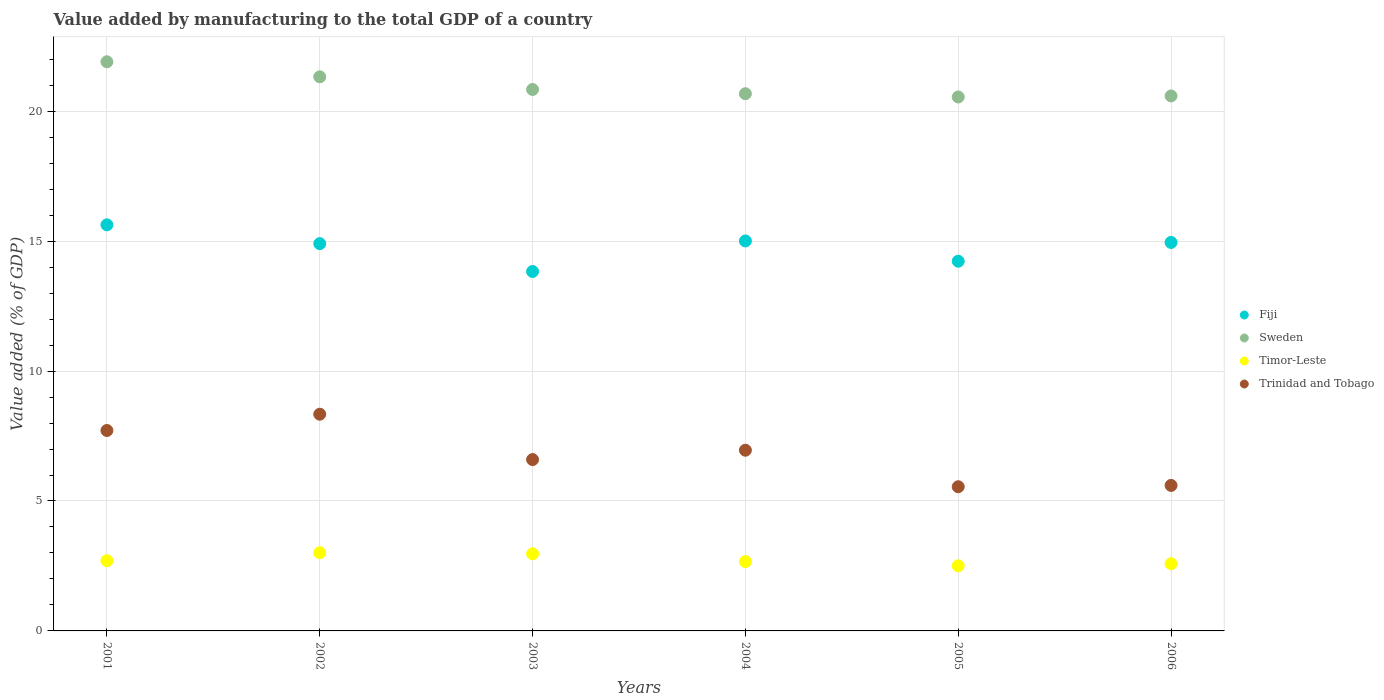How many different coloured dotlines are there?
Ensure brevity in your answer.  4. Is the number of dotlines equal to the number of legend labels?
Make the answer very short. Yes. What is the value added by manufacturing to the total GDP in Sweden in 2006?
Provide a short and direct response. 20.59. Across all years, what is the maximum value added by manufacturing to the total GDP in Fiji?
Keep it short and to the point. 15.63. Across all years, what is the minimum value added by manufacturing to the total GDP in Timor-Leste?
Offer a very short reply. 2.51. What is the total value added by manufacturing to the total GDP in Timor-Leste in the graph?
Offer a very short reply. 16.44. What is the difference between the value added by manufacturing to the total GDP in Trinidad and Tobago in 2002 and that in 2003?
Provide a short and direct response. 1.75. What is the difference between the value added by manufacturing to the total GDP in Timor-Leste in 2004 and the value added by manufacturing to the total GDP in Sweden in 2003?
Your answer should be compact. -18.17. What is the average value added by manufacturing to the total GDP in Sweden per year?
Provide a short and direct response. 20.98. In the year 2004, what is the difference between the value added by manufacturing to the total GDP in Timor-Leste and value added by manufacturing to the total GDP in Trinidad and Tobago?
Your response must be concise. -4.29. What is the ratio of the value added by manufacturing to the total GDP in Trinidad and Tobago in 2004 to that in 2005?
Keep it short and to the point. 1.25. Is the difference between the value added by manufacturing to the total GDP in Timor-Leste in 2002 and 2006 greater than the difference between the value added by manufacturing to the total GDP in Trinidad and Tobago in 2002 and 2006?
Your answer should be compact. No. What is the difference between the highest and the second highest value added by manufacturing to the total GDP in Trinidad and Tobago?
Your response must be concise. 0.63. What is the difference between the highest and the lowest value added by manufacturing to the total GDP in Sweden?
Your response must be concise. 1.35. Is the sum of the value added by manufacturing to the total GDP in Sweden in 2003 and 2005 greater than the maximum value added by manufacturing to the total GDP in Trinidad and Tobago across all years?
Offer a terse response. Yes. Is the value added by manufacturing to the total GDP in Sweden strictly greater than the value added by manufacturing to the total GDP in Timor-Leste over the years?
Ensure brevity in your answer.  Yes. How many dotlines are there?
Provide a short and direct response. 4. How many years are there in the graph?
Make the answer very short. 6. Are the values on the major ticks of Y-axis written in scientific E-notation?
Offer a terse response. No. What is the title of the graph?
Make the answer very short. Value added by manufacturing to the total GDP of a country. Does "Lao PDR" appear as one of the legend labels in the graph?
Ensure brevity in your answer.  No. What is the label or title of the X-axis?
Your response must be concise. Years. What is the label or title of the Y-axis?
Give a very brief answer. Value added (% of GDP). What is the Value added (% of GDP) of Fiji in 2001?
Offer a terse response. 15.63. What is the Value added (% of GDP) in Sweden in 2001?
Your answer should be compact. 21.9. What is the Value added (% of GDP) in Timor-Leste in 2001?
Provide a succinct answer. 2.7. What is the Value added (% of GDP) in Trinidad and Tobago in 2001?
Ensure brevity in your answer.  7.71. What is the Value added (% of GDP) of Fiji in 2002?
Offer a very short reply. 14.9. What is the Value added (% of GDP) of Sweden in 2002?
Provide a short and direct response. 21.32. What is the Value added (% of GDP) in Timor-Leste in 2002?
Ensure brevity in your answer.  3.01. What is the Value added (% of GDP) of Trinidad and Tobago in 2002?
Offer a very short reply. 8.34. What is the Value added (% of GDP) of Fiji in 2003?
Offer a very short reply. 13.83. What is the Value added (% of GDP) of Sweden in 2003?
Provide a short and direct response. 20.84. What is the Value added (% of GDP) in Timor-Leste in 2003?
Ensure brevity in your answer.  2.97. What is the Value added (% of GDP) of Trinidad and Tobago in 2003?
Keep it short and to the point. 6.59. What is the Value added (% of GDP) in Fiji in 2004?
Make the answer very short. 15.01. What is the Value added (% of GDP) in Sweden in 2004?
Give a very brief answer. 20.67. What is the Value added (% of GDP) of Timor-Leste in 2004?
Keep it short and to the point. 2.67. What is the Value added (% of GDP) in Trinidad and Tobago in 2004?
Give a very brief answer. 6.95. What is the Value added (% of GDP) in Fiji in 2005?
Make the answer very short. 14.23. What is the Value added (% of GDP) in Sweden in 2005?
Give a very brief answer. 20.55. What is the Value added (% of GDP) in Timor-Leste in 2005?
Your answer should be compact. 2.51. What is the Value added (% of GDP) of Trinidad and Tobago in 2005?
Ensure brevity in your answer.  5.55. What is the Value added (% of GDP) in Fiji in 2006?
Ensure brevity in your answer.  14.95. What is the Value added (% of GDP) in Sweden in 2006?
Keep it short and to the point. 20.59. What is the Value added (% of GDP) of Timor-Leste in 2006?
Your response must be concise. 2.59. What is the Value added (% of GDP) of Trinidad and Tobago in 2006?
Give a very brief answer. 5.6. Across all years, what is the maximum Value added (% of GDP) of Fiji?
Ensure brevity in your answer.  15.63. Across all years, what is the maximum Value added (% of GDP) in Sweden?
Your response must be concise. 21.9. Across all years, what is the maximum Value added (% of GDP) of Timor-Leste?
Your answer should be compact. 3.01. Across all years, what is the maximum Value added (% of GDP) in Trinidad and Tobago?
Provide a succinct answer. 8.34. Across all years, what is the minimum Value added (% of GDP) in Fiji?
Provide a succinct answer. 13.83. Across all years, what is the minimum Value added (% of GDP) in Sweden?
Provide a short and direct response. 20.55. Across all years, what is the minimum Value added (% of GDP) in Timor-Leste?
Provide a short and direct response. 2.51. Across all years, what is the minimum Value added (% of GDP) of Trinidad and Tobago?
Keep it short and to the point. 5.55. What is the total Value added (% of GDP) of Fiji in the graph?
Keep it short and to the point. 88.54. What is the total Value added (% of GDP) of Sweden in the graph?
Keep it short and to the point. 125.87. What is the total Value added (% of GDP) in Timor-Leste in the graph?
Keep it short and to the point. 16.44. What is the total Value added (% of GDP) in Trinidad and Tobago in the graph?
Your answer should be very brief. 40.75. What is the difference between the Value added (% of GDP) of Fiji in 2001 and that in 2002?
Your response must be concise. 0.72. What is the difference between the Value added (% of GDP) of Sweden in 2001 and that in 2002?
Ensure brevity in your answer.  0.58. What is the difference between the Value added (% of GDP) in Timor-Leste in 2001 and that in 2002?
Give a very brief answer. -0.31. What is the difference between the Value added (% of GDP) in Trinidad and Tobago in 2001 and that in 2002?
Ensure brevity in your answer.  -0.63. What is the difference between the Value added (% of GDP) in Fiji in 2001 and that in 2003?
Your response must be concise. 1.8. What is the difference between the Value added (% of GDP) of Sweden in 2001 and that in 2003?
Your answer should be very brief. 1.07. What is the difference between the Value added (% of GDP) in Timor-Leste in 2001 and that in 2003?
Your answer should be compact. -0.27. What is the difference between the Value added (% of GDP) in Trinidad and Tobago in 2001 and that in 2003?
Give a very brief answer. 1.12. What is the difference between the Value added (% of GDP) in Fiji in 2001 and that in 2004?
Your answer should be very brief. 0.62. What is the difference between the Value added (% of GDP) of Sweden in 2001 and that in 2004?
Your response must be concise. 1.23. What is the difference between the Value added (% of GDP) in Timor-Leste in 2001 and that in 2004?
Your answer should be very brief. 0.04. What is the difference between the Value added (% of GDP) in Trinidad and Tobago in 2001 and that in 2004?
Ensure brevity in your answer.  0.76. What is the difference between the Value added (% of GDP) of Fiji in 2001 and that in 2005?
Offer a very short reply. 1.4. What is the difference between the Value added (% of GDP) of Sweden in 2001 and that in 2005?
Your response must be concise. 1.35. What is the difference between the Value added (% of GDP) in Timor-Leste in 2001 and that in 2005?
Your response must be concise. 0.2. What is the difference between the Value added (% of GDP) in Trinidad and Tobago in 2001 and that in 2005?
Keep it short and to the point. 2.16. What is the difference between the Value added (% of GDP) of Fiji in 2001 and that in 2006?
Offer a very short reply. 0.68. What is the difference between the Value added (% of GDP) of Sweden in 2001 and that in 2006?
Your answer should be compact. 1.31. What is the difference between the Value added (% of GDP) of Timor-Leste in 2001 and that in 2006?
Your response must be concise. 0.12. What is the difference between the Value added (% of GDP) of Trinidad and Tobago in 2001 and that in 2006?
Offer a terse response. 2.11. What is the difference between the Value added (% of GDP) in Fiji in 2002 and that in 2003?
Your answer should be compact. 1.07. What is the difference between the Value added (% of GDP) of Sweden in 2002 and that in 2003?
Offer a terse response. 0.49. What is the difference between the Value added (% of GDP) in Timor-Leste in 2002 and that in 2003?
Provide a short and direct response. 0.04. What is the difference between the Value added (% of GDP) of Trinidad and Tobago in 2002 and that in 2003?
Keep it short and to the point. 1.75. What is the difference between the Value added (% of GDP) in Fiji in 2002 and that in 2004?
Ensure brevity in your answer.  -0.1. What is the difference between the Value added (% of GDP) in Sweden in 2002 and that in 2004?
Provide a short and direct response. 0.65. What is the difference between the Value added (% of GDP) in Timor-Leste in 2002 and that in 2004?
Offer a very short reply. 0.34. What is the difference between the Value added (% of GDP) of Trinidad and Tobago in 2002 and that in 2004?
Offer a very short reply. 1.39. What is the difference between the Value added (% of GDP) in Fiji in 2002 and that in 2005?
Provide a succinct answer. 0.68. What is the difference between the Value added (% of GDP) of Sweden in 2002 and that in 2005?
Offer a terse response. 0.78. What is the difference between the Value added (% of GDP) in Timor-Leste in 2002 and that in 2005?
Make the answer very short. 0.5. What is the difference between the Value added (% of GDP) in Trinidad and Tobago in 2002 and that in 2005?
Your answer should be very brief. 2.79. What is the difference between the Value added (% of GDP) in Fiji in 2002 and that in 2006?
Ensure brevity in your answer.  -0.05. What is the difference between the Value added (% of GDP) of Sweden in 2002 and that in 2006?
Make the answer very short. 0.74. What is the difference between the Value added (% of GDP) in Timor-Leste in 2002 and that in 2006?
Keep it short and to the point. 0.42. What is the difference between the Value added (% of GDP) of Trinidad and Tobago in 2002 and that in 2006?
Keep it short and to the point. 2.74. What is the difference between the Value added (% of GDP) of Fiji in 2003 and that in 2004?
Ensure brevity in your answer.  -1.18. What is the difference between the Value added (% of GDP) of Sweden in 2003 and that in 2004?
Make the answer very short. 0.16. What is the difference between the Value added (% of GDP) in Timor-Leste in 2003 and that in 2004?
Ensure brevity in your answer.  0.3. What is the difference between the Value added (% of GDP) of Trinidad and Tobago in 2003 and that in 2004?
Offer a terse response. -0.36. What is the difference between the Value added (% of GDP) in Fiji in 2003 and that in 2005?
Your answer should be very brief. -0.4. What is the difference between the Value added (% of GDP) of Sweden in 2003 and that in 2005?
Make the answer very short. 0.29. What is the difference between the Value added (% of GDP) of Timor-Leste in 2003 and that in 2005?
Offer a terse response. 0.46. What is the difference between the Value added (% of GDP) in Trinidad and Tobago in 2003 and that in 2005?
Provide a short and direct response. 1.05. What is the difference between the Value added (% of GDP) of Fiji in 2003 and that in 2006?
Give a very brief answer. -1.12. What is the difference between the Value added (% of GDP) of Sweden in 2003 and that in 2006?
Your response must be concise. 0.25. What is the difference between the Value added (% of GDP) in Timor-Leste in 2003 and that in 2006?
Make the answer very short. 0.38. What is the difference between the Value added (% of GDP) of Trinidad and Tobago in 2003 and that in 2006?
Offer a terse response. 0.99. What is the difference between the Value added (% of GDP) in Fiji in 2004 and that in 2005?
Give a very brief answer. 0.78. What is the difference between the Value added (% of GDP) of Sweden in 2004 and that in 2005?
Offer a very short reply. 0.13. What is the difference between the Value added (% of GDP) in Timor-Leste in 2004 and that in 2005?
Provide a succinct answer. 0.16. What is the difference between the Value added (% of GDP) in Trinidad and Tobago in 2004 and that in 2005?
Offer a very short reply. 1.41. What is the difference between the Value added (% of GDP) in Fiji in 2004 and that in 2006?
Offer a very short reply. 0.06. What is the difference between the Value added (% of GDP) in Sweden in 2004 and that in 2006?
Your answer should be very brief. 0.09. What is the difference between the Value added (% of GDP) of Timor-Leste in 2004 and that in 2006?
Make the answer very short. 0.08. What is the difference between the Value added (% of GDP) of Trinidad and Tobago in 2004 and that in 2006?
Make the answer very short. 1.35. What is the difference between the Value added (% of GDP) in Fiji in 2005 and that in 2006?
Offer a terse response. -0.72. What is the difference between the Value added (% of GDP) in Sweden in 2005 and that in 2006?
Make the answer very short. -0.04. What is the difference between the Value added (% of GDP) in Timor-Leste in 2005 and that in 2006?
Provide a succinct answer. -0.08. What is the difference between the Value added (% of GDP) of Trinidad and Tobago in 2005 and that in 2006?
Ensure brevity in your answer.  -0.05. What is the difference between the Value added (% of GDP) of Fiji in 2001 and the Value added (% of GDP) of Sweden in 2002?
Make the answer very short. -5.7. What is the difference between the Value added (% of GDP) of Fiji in 2001 and the Value added (% of GDP) of Timor-Leste in 2002?
Offer a very short reply. 12.62. What is the difference between the Value added (% of GDP) of Fiji in 2001 and the Value added (% of GDP) of Trinidad and Tobago in 2002?
Provide a succinct answer. 7.29. What is the difference between the Value added (% of GDP) in Sweden in 2001 and the Value added (% of GDP) in Timor-Leste in 2002?
Your answer should be very brief. 18.89. What is the difference between the Value added (% of GDP) in Sweden in 2001 and the Value added (% of GDP) in Trinidad and Tobago in 2002?
Your answer should be very brief. 13.56. What is the difference between the Value added (% of GDP) of Timor-Leste in 2001 and the Value added (% of GDP) of Trinidad and Tobago in 2002?
Give a very brief answer. -5.64. What is the difference between the Value added (% of GDP) of Fiji in 2001 and the Value added (% of GDP) of Sweden in 2003?
Give a very brief answer. -5.21. What is the difference between the Value added (% of GDP) of Fiji in 2001 and the Value added (% of GDP) of Timor-Leste in 2003?
Keep it short and to the point. 12.66. What is the difference between the Value added (% of GDP) in Fiji in 2001 and the Value added (% of GDP) in Trinidad and Tobago in 2003?
Provide a short and direct response. 9.03. What is the difference between the Value added (% of GDP) of Sweden in 2001 and the Value added (% of GDP) of Timor-Leste in 2003?
Your answer should be compact. 18.93. What is the difference between the Value added (% of GDP) in Sweden in 2001 and the Value added (% of GDP) in Trinidad and Tobago in 2003?
Provide a succinct answer. 15.31. What is the difference between the Value added (% of GDP) in Timor-Leste in 2001 and the Value added (% of GDP) in Trinidad and Tobago in 2003?
Provide a short and direct response. -3.89. What is the difference between the Value added (% of GDP) of Fiji in 2001 and the Value added (% of GDP) of Sweden in 2004?
Offer a very short reply. -5.05. What is the difference between the Value added (% of GDP) in Fiji in 2001 and the Value added (% of GDP) in Timor-Leste in 2004?
Make the answer very short. 12.96. What is the difference between the Value added (% of GDP) of Fiji in 2001 and the Value added (% of GDP) of Trinidad and Tobago in 2004?
Offer a very short reply. 8.67. What is the difference between the Value added (% of GDP) of Sweden in 2001 and the Value added (% of GDP) of Timor-Leste in 2004?
Provide a short and direct response. 19.24. What is the difference between the Value added (% of GDP) in Sweden in 2001 and the Value added (% of GDP) in Trinidad and Tobago in 2004?
Your answer should be very brief. 14.95. What is the difference between the Value added (% of GDP) in Timor-Leste in 2001 and the Value added (% of GDP) in Trinidad and Tobago in 2004?
Offer a terse response. -4.25. What is the difference between the Value added (% of GDP) of Fiji in 2001 and the Value added (% of GDP) of Sweden in 2005?
Offer a very short reply. -4.92. What is the difference between the Value added (% of GDP) in Fiji in 2001 and the Value added (% of GDP) in Timor-Leste in 2005?
Make the answer very short. 13.12. What is the difference between the Value added (% of GDP) of Fiji in 2001 and the Value added (% of GDP) of Trinidad and Tobago in 2005?
Your answer should be compact. 10.08. What is the difference between the Value added (% of GDP) in Sweden in 2001 and the Value added (% of GDP) in Timor-Leste in 2005?
Offer a very short reply. 19.4. What is the difference between the Value added (% of GDP) in Sweden in 2001 and the Value added (% of GDP) in Trinidad and Tobago in 2005?
Make the answer very short. 16.35. What is the difference between the Value added (% of GDP) of Timor-Leste in 2001 and the Value added (% of GDP) of Trinidad and Tobago in 2005?
Provide a succinct answer. -2.85. What is the difference between the Value added (% of GDP) of Fiji in 2001 and the Value added (% of GDP) of Sweden in 2006?
Keep it short and to the point. -4.96. What is the difference between the Value added (% of GDP) of Fiji in 2001 and the Value added (% of GDP) of Timor-Leste in 2006?
Keep it short and to the point. 13.04. What is the difference between the Value added (% of GDP) in Fiji in 2001 and the Value added (% of GDP) in Trinidad and Tobago in 2006?
Keep it short and to the point. 10.03. What is the difference between the Value added (% of GDP) of Sweden in 2001 and the Value added (% of GDP) of Timor-Leste in 2006?
Give a very brief answer. 19.32. What is the difference between the Value added (% of GDP) of Sweden in 2001 and the Value added (% of GDP) of Trinidad and Tobago in 2006?
Keep it short and to the point. 16.3. What is the difference between the Value added (% of GDP) of Timor-Leste in 2001 and the Value added (% of GDP) of Trinidad and Tobago in 2006?
Provide a short and direct response. -2.9. What is the difference between the Value added (% of GDP) of Fiji in 2002 and the Value added (% of GDP) of Sweden in 2003?
Provide a succinct answer. -5.93. What is the difference between the Value added (% of GDP) in Fiji in 2002 and the Value added (% of GDP) in Timor-Leste in 2003?
Give a very brief answer. 11.94. What is the difference between the Value added (% of GDP) of Fiji in 2002 and the Value added (% of GDP) of Trinidad and Tobago in 2003?
Your response must be concise. 8.31. What is the difference between the Value added (% of GDP) in Sweden in 2002 and the Value added (% of GDP) in Timor-Leste in 2003?
Your response must be concise. 18.35. What is the difference between the Value added (% of GDP) in Sweden in 2002 and the Value added (% of GDP) in Trinidad and Tobago in 2003?
Ensure brevity in your answer.  14.73. What is the difference between the Value added (% of GDP) in Timor-Leste in 2002 and the Value added (% of GDP) in Trinidad and Tobago in 2003?
Your response must be concise. -3.58. What is the difference between the Value added (% of GDP) in Fiji in 2002 and the Value added (% of GDP) in Sweden in 2004?
Ensure brevity in your answer.  -5.77. What is the difference between the Value added (% of GDP) in Fiji in 2002 and the Value added (% of GDP) in Timor-Leste in 2004?
Provide a succinct answer. 12.24. What is the difference between the Value added (% of GDP) of Fiji in 2002 and the Value added (% of GDP) of Trinidad and Tobago in 2004?
Ensure brevity in your answer.  7.95. What is the difference between the Value added (% of GDP) of Sweden in 2002 and the Value added (% of GDP) of Timor-Leste in 2004?
Ensure brevity in your answer.  18.66. What is the difference between the Value added (% of GDP) in Sweden in 2002 and the Value added (% of GDP) in Trinidad and Tobago in 2004?
Ensure brevity in your answer.  14.37. What is the difference between the Value added (% of GDP) in Timor-Leste in 2002 and the Value added (% of GDP) in Trinidad and Tobago in 2004?
Provide a succinct answer. -3.94. What is the difference between the Value added (% of GDP) of Fiji in 2002 and the Value added (% of GDP) of Sweden in 2005?
Provide a short and direct response. -5.64. What is the difference between the Value added (% of GDP) in Fiji in 2002 and the Value added (% of GDP) in Timor-Leste in 2005?
Keep it short and to the point. 12.4. What is the difference between the Value added (% of GDP) of Fiji in 2002 and the Value added (% of GDP) of Trinidad and Tobago in 2005?
Provide a short and direct response. 9.35. What is the difference between the Value added (% of GDP) in Sweden in 2002 and the Value added (% of GDP) in Timor-Leste in 2005?
Keep it short and to the point. 18.82. What is the difference between the Value added (% of GDP) in Sweden in 2002 and the Value added (% of GDP) in Trinidad and Tobago in 2005?
Offer a very short reply. 15.77. What is the difference between the Value added (% of GDP) of Timor-Leste in 2002 and the Value added (% of GDP) of Trinidad and Tobago in 2005?
Offer a terse response. -2.54. What is the difference between the Value added (% of GDP) of Fiji in 2002 and the Value added (% of GDP) of Sweden in 2006?
Your answer should be very brief. -5.68. What is the difference between the Value added (% of GDP) in Fiji in 2002 and the Value added (% of GDP) in Timor-Leste in 2006?
Your answer should be compact. 12.32. What is the difference between the Value added (% of GDP) in Fiji in 2002 and the Value added (% of GDP) in Trinidad and Tobago in 2006?
Offer a very short reply. 9.3. What is the difference between the Value added (% of GDP) of Sweden in 2002 and the Value added (% of GDP) of Timor-Leste in 2006?
Your response must be concise. 18.74. What is the difference between the Value added (% of GDP) of Sweden in 2002 and the Value added (% of GDP) of Trinidad and Tobago in 2006?
Give a very brief answer. 15.72. What is the difference between the Value added (% of GDP) of Timor-Leste in 2002 and the Value added (% of GDP) of Trinidad and Tobago in 2006?
Provide a succinct answer. -2.59. What is the difference between the Value added (% of GDP) of Fiji in 2003 and the Value added (% of GDP) of Sweden in 2004?
Make the answer very short. -6.84. What is the difference between the Value added (% of GDP) in Fiji in 2003 and the Value added (% of GDP) in Timor-Leste in 2004?
Offer a terse response. 11.16. What is the difference between the Value added (% of GDP) of Fiji in 2003 and the Value added (% of GDP) of Trinidad and Tobago in 2004?
Your response must be concise. 6.88. What is the difference between the Value added (% of GDP) of Sweden in 2003 and the Value added (% of GDP) of Timor-Leste in 2004?
Your response must be concise. 18.17. What is the difference between the Value added (% of GDP) in Sweden in 2003 and the Value added (% of GDP) in Trinidad and Tobago in 2004?
Offer a terse response. 13.88. What is the difference between the Value added (% of GDP) in Timor-Leste in 2003 and the Value added (% of GDP) in Trinidad and Tobago in 2004?
Provide a succinct answer. -3.99. What is the difference between the Value added (% of GDP) in Fiji in 2003 and the Value added (% of GDP) in Sweden in 2005?
Your response must be concise. -6.72. What is the difference between the Value added (% of GDP) of Fiji in 2003 and the Value added (% of GDP) of Timor-Leste in 2005?
Ensure brevity in your answer.  11.33. What is the difference between the Value added (% of GDP) in Fiji in 2003 and the Value added (% of GDP) in Trinidad and Tobago in 2005?
Give a very brief answer. 8.28. What is the difference between the Value added (% of GDP) in Sweden in 2003 and the Value added (% of GDP) in Timor-Leste in 2005?
Your answer should be compact. 18.33. What is the difference between the Value added (% of GDP) of Sweden in 2003 and the Value added (% of GDP) of Trinidad and Tobago in 2005?
Offer a terse response. 15.29. What is the difference between the Value added (% of GDP) in Timor-Leste in 2003 and the Value added (% of GDP) in Trinidad and Tobago in 2005?
Your answer should be very brief. -2.58. What is the difference between the Value added (% of GDP) in Fiji in 2003 and the Value added (% of GDP) in Sweden in 2006?
Provide a short and direct response. -6.76. What is the difference between the Value added (% of GDP) in Fiji in 2003 and the Value added (% of GDP) in Timor-Leste in 2006?
Offer a terse response. 11.25. What is the difference between the Value added (% of GDP) in Fiji in 2003 and the Value added (% of GDP) in Trinidad and Tobago in 2006?
Your answer should be compact. 8.23. What is the difference between the Value added (% of GDP) of Sweden in 2003 and the Value added (% of GDP) of Timor-Leste in 2006?
Give a very brief answer. 18.25. What is the difference between the Value added (% of GDP) in Sweden in 2003 and the Value added (% of GDP) in Trinidad and Tobago in 2006?
Provide a succinct answer. 15.24. What is the difference between the Value added (% of GDP) in Timor-Leste in 2003 and the Value added (% of GDP) in Trinidad and Tobago in 2006?
Give a very brief answer. -2.63. What is the difference between the Value added (% of GDP) of Fiji in 2004 and the Value added (% of GDP) of Sweden in 2005?
Your answer should be very brief. -5.54. What is the difference between the Value added (% of GDP) in Fiji in 2004 and the Value added (% of GDP) in Timor-Leste in 2005?
Offer a very short reply. 12.5. What is the difference between the Value added (% of GDP) of Fiji in 2004 and the Value added (% of GDP) of Trinidad and Tobago in 2005?
Offer a terse response. 9.46. What is the difference between the Value added (% of GDP) of Sweden in 2004 and the Value added (% of GDP) of Timor-Leste in 2005?
Provide a short and direct response. 18.17. What is the difference between the Value added (% of GDP) in Sweden in 2004 and the Value added (% of GDP) in Trinidad and Tobago in 2005?
Provide a succinct answer. 15.12. What is the difference between the Value added (% of GDP) in Timor-Leste in 2004 and the Value added (% of GDP) in Trinidad and Tobago in 2005?
Give a very brief answer. -2.88. What is the difference between the Value added (% of GDP) in Fiji in 2004 and the Value added (% of GDP) in Sweden in 2006?
Give a very brief answer. -5.58. What is the difference between the Value added (% of GDP) in Fiji in 2004 and the Value added (% of GDP) in Timor-Leste in 2006?
Keep it short and to the point. 12.42. What is the difference between the Value added (% of GDP) in Fiji in 2004 and the Value added (% of GDP) in Trinidad and Tobago in 2006?
Your answer should be compact. 9.41. What is the difference between the Value added (% of GDP) of Sweden in 2004 and the Value added (% of GDP) of Timor-Leste in 2006?
Your response must be concise. 18.09. What is the difference between the Value added (% of GDP) of Sweden in 2004 and the Value added (% of GDP) of Trinidad and Tobago in 2006?
Your answer should be compact. 15.07. What is the difference between the Value added (% of GDP) in Timor-Leste in 2004 and the Value added (% of GDP) in Trinidad and Tobago in 2006?
Provide a short and direct response. -2.93. What is the difference between the Value added (% of GDP) of Fiji in 2005 and the Value added (% of GDP) of Sweden in 2006?
Offer a terse response. -6.36. What is the difference between the Value added (% of GDP) in Fiji in 2005 and the Value added (% of GDP) in Timor-Leste in 2006?
Your response must be concise. 11.64. What is the difference between the Value added (% of GDP) of Fiji in 2005 and the Value added (% of GDP) of Trinidad and Tobago in 2006?
Offer a terse response. 8.63. What is the difference between the Value added (% of GDP) of Sweden in 2005 and the Value added (% of GDP) of Timor-Leste in 2006?
Your answer should be compact. 17.96. What is the difference between the Value added (% of GDP) in Sweden in 2005 and the Value added (% of GDP) in Trinidad and Tobago in 2006?
Provide a short and direct response. 14.95. What is the difference between the Value added (% of GDP) in Timor-Leste in 2005 and the Value added (% of GDP) in Trinidad and Tobago in 2006?
Provide a short and direct response. -3.09. What is the average Value added (% of GDP) of Fiji per year?
Keep it short and to the point. 14.76. What is the average Value added (% of GDP) in Sweden per year?
Give a very brief answer. 20.98. What is the average Value added (% of GDP) of Timor-Leste per year?
Provide a succinct answer. 2.74. What is the average Value added (% of GDP) in Trinidad and Tobago per year?
Offer a terse response. 6.79. In the year 2001, what is the difference between the Value added (% of GDP) of Fiji and Value added (% of GDP) of Sweden?
Provide a succinct answer. -6.28. In the year 2001, what is the difference between the Value added (% of GDP) in Fiji and Value added (% of GDP) in Timor-Leste?
Your response must be concise. 12.92. In the year 2001, what is the difference between the Value added (% of GDP) in Fiji and Value added (% of GDP) in Trinidad and Tobago?
Offer a very short reply. 7.91. In the year 2001, what is the difference between the Value added (% of GDP) in Sweden and Value added (% of GDP) in Timor-Leste?
Your answer should be compact. 19.2. In the year 2001, what is the difference between the Value added (% of GDP) of Sweden and Value added (% of GDP) of Trinidad and Tobago?
Keep it short and to the point. 14.19. In the year 2001, what is the difference between the Value added (% of GDP) in Timor-Leste and Value added (% of GDP) in Trinidad and Tobago?
Your response must be concise. -5.01. In the year 2002, what is the difference between the Value added (% of GDP) of Fiji and Value added (% of GDP) of Sweden?
Your answer should be compact. -6.42. In the year 2002, what is the difference between the Value added (% of GDP) in Fiji and Value added (% of GDP) in Timor-Leste?
Offer a very short reply. 11.89. In the year 2002, what is the difference between the Value added (% of GDP) of Fiji and Value added (% of GDP) of Trinidad and Tobago?
Your answer should be compact. 6.56. In the year 2002, what is the difference between the Value added (% of GDP) of Sweden and Value added (% of GDP) of Timor-Leste?
Your answer should be very brief. 18.31. In the year 2002, what is the difference between the Value added (% of GDP) in Sweden and Value added (% of GDP) in Trinidad and Tobago?
Your response must be concise. 12.98. In the year 2002, what is the difference between the Value added (% of GDP) of Timor-Leste and Value added (% of GDP) of Trinidad and Tobago?
Keep it short and to the point. -5.33. In the year 2003, what is the difference between the Value added (% of GDP) of Fiji and Value added (% of GDP) of Sweden?
Provide a short and direct response. -7. In the year 2003, what is the difference between the Value added (% of GDP) of Fiji and Value added (% of GDP) of Timor-Leste?
Give a very brief answer. 10.86. In the year 2003, what is the difference between the Value added (% of GDP) in Fiji and Value added (% of GDP) in Trinidad and Tobago?
Provide a succinct answer. 7.24. In the year 2003, what is the difference between the Value added (% of GDP) of Sweden and Value added (% of GDP) of Timor-Leste?
Offer a terse response. 17.87. In the year 2003, what is the difference between the Value added (% of GDP) of Sweden and Value added (% of GDP) of Trinidad and Tobago?
Provide a short and direct response. 14.24. In the year 2003, what is the difference between the Value added (% of GDP) in Timor-Leste and Value added (% of GDP) in Trinidad and Tobago?
Offer a very short reply. -3.63. In the year 2004, what is the difference between the Value added (% of GDP) of Fiji and Value added (% of GDP) of Sweden?
Keep it short and to the point. -5.67. In the year 2004, what is the difference between the Value added (% of GDP) in Fiji and Value added (% of GDP) in Timor-Leste?
Keep it short and to the point. 12.34. In the year 2004, what is the difference between the Value added (% of GDP) in Fiji and Value added (% of GDP) in Trinidad and Tobago?
Provide a short and direct response. 8.05. In the year 2004, what is the difference between the Value added (% of GDP) in Sweden and Value added (% of GDP) in Timor-Leste?
Your response must be concise. 18.01. In the year 2004, what is the difference between the Value added (% of GDP) in Sweden and Value added (% of GDP) in Trinidad and Tobago?
Provide a succinct answer. 13.72. In the year 2004, what is the difference between the Value added (% of GDP) in Timor-Leste and Value added (% of GDP) in Trinidad and Tobago?
Ensure brevity in your answer.  -4.29. In the year 2005, what is the difference between the Value added (% of GDP) in Fiji and Value added (% of GDP) in Sweden?
Ensure brevity in your answer.  -6.32. In the year 2005, what is the difference between the Value added (% of GDP) in Fiji and Value added (% of GDP) in Timor-Leste?
Keep it short and to the point. 11.72. In the year 2005, what is the difference between the Value added (% of GDP) of Fiji and Value added (% of GDP) of Trinidad and Tobago?
Your answer should be compact. 8.68. In the year 2005, what is the difference between the Value added (% of GDP) of Sweden and Value added (% of GDP) of Timor-Leste?
Your answer should be very brief. 18.04. In the year 2005, what is the difference between the Value added (% of GDP) of Sweden and Value added (% of GDP) of Trinidad and Tobago?
Provide a succinct answer. 15. In the year 2005, what is the difference between the Value added (% of GDP) in Timor-Leste and Value added (% of GDP) in Trinidad and Tobago?
Your response must be concise. -3.04. In the year 2006, what is the difference between the Value added (% of GDP) in Fiji and Value added (% of GDP) in Sweden?
Provide a short and direct response. -5.64. In the year 2006, what is the difference between the Value added (% of GDP) in Fiji and Value added (% of GDP) in Timor-Leste?
Your answer should be very brief. 12.36. In the year 2006, what is the difference between the Value added (% of GDP) of Fiji and Value added (% of GDP) of Trinidad and Tobago?
Offer a very short reply. 9.35. In the year 2006, what is the difference between the Value added (% of GDP) in Sweden and Value added (% of GDP) in Timor-Leste?
Your answer should be compact. 18. In the year 2006, what is the difference between the Value added (% of GDP) of Sweden and Value added (% of GDP) of Trinidad and Tobago?
Provide a succinct answer. 14.99. In the year 2006, what is the difference between the Value added (% of GDP) of Timor-Leste and Value added (% of GDP) of Trinidad and Tobago?
Your response must be concise. -3.01. What is the ratio of the Value added (% of GDP) in Fiji in 2001 to that in 2002?
Keep it short and to the point. 1.05. What is the ratio of the Value added (% of GDP) in Sweden in 2001 to that in 2002?
Provide a short and direct response. 1.03. What is the ratio of the Value added (% of GDP) of Timor-Leste in 2001 to that in 2002?
Provide a succinct answer. 0.9. What is the ratio of the Value added (% of GDP) of Trinidad and Tobago in 2001 to that in 2002?
Your answer should be very brief. 0.92. What is the ratio of the Value added (% of GDP) in Fiji in 2001 to that in 2003?
Offer a very short reply. 1.13. What is the ratio of the Value added (% of GDP) in Sweden in 2001 to that in 2003?
Offer a very short reply. 1.05. What is the ratio of the Value added (% of GDP) in Timor-Leste in 2001 to that in 2003?
Offer a very short reply. 0.91. What is the ratio of the Value added (% of GDP) in Trinidad and Tobago in 2001 to that in 2003?
Your answer should be compact. 1.17. What is the ratio of the Value added (% of GDP) of Fiji in 2001 to that in 2004?
Ensure brevity in your answer.  1.04. What is the ratio of the Value added (% of GDP) in Sweden in 2001 to that in 2004?
Keep it short and to the point. 1.06. What is the ratio of the Value added (% of GDP) of Timor-Leste in 2001 to that in 2004?
Give a very brief answer. 1.01. What is the ratio of the Value added (% of GDP) in Trinidad and Tobago in 2001 to that in 2004?
Ensure brevity in your answer.  1.11. What is the ratio of the Value added (% of GDP) of Fiji in 2001 to that in 2005?
Give a very brief answer. 1.1. What is the ratio of the Value added (% of GDP) of Sweden in 2001 to that in 2005?
Your answer should be compact. 1.07. What is the ratio of the Value added (% of GDP) of Timor-Leste in 2001 to that in 2005?
Ensure brevity in your answer.  1.08. What is the ratio of the Value added (% of GDP) in Trinidad and Tobago in 2001 to that in 2005?
Give a very brief answer. 1.39. What is the ratio of the Value added (% of GDP) in Fiji in 2001 to that in 2006?
Provide a succinct answer. 1.05. What is the ratio of the Value added (% of GDP) in Sweden in 2001 to that in 2006?
Your response must be concise. 1.06. What is the ratio of the Value added (% of GDP) in Timor-Leste in 2001 to that in 2006?
Provide a succinct answer. 1.04. What is the ratio of the Value added (% of GDP) of Trinidad and Tobago in 2001 to that in 2006?
Offer a terse response. 1.38. What is the ratio of the Value added (% of GDP) of Fiji in 2002 to that in 2003?
Offer a very short reply. 1.08. What is the ratio of the Value added (% of GDP) in Sweden in 2002 to that in 2003?
Make the answer very short. 1.02. What is the ratio of the Value added (% of GDP) in Timor-Leste in 2002 to that in 2003?
Give a very brief answer. 1.01. What is the ratio of the Value added (% of GDP) of Trinidad and Tobago in 2002 to that in 2003?
Make the answer very short. 1.26. What is the ratio of the Value added (% of GDP) in Fiji in 2002 to that in 2004?
Provide a succinct answer. 0.99. What is the ratio of the Value added (% of GDP) in Sweden in 2002 to that in 2004?
Provide a short and direct response. 1.03. What is the ratio of the Value added (% of GDP) of Timor-Leste in 2002 to that in 2004?
Keep it short and to the point. 1.13. What is the ratio of the Value added (% of GDP) in Trinidad and Tobago in 2002 to that in 2004?
Ensure brevity in your answer.  1.2. What is the ratio of the Value added (% of GDP) of Fiji in 2002 to that in 2005?
Offer a terse response. 1.05. What is the ratio of the Value added (% of GDP) of Sweden in 2002 to that in 2005?
Offer a terse response. 1.04. What is the ratio of the Value added (% of GDP) in Timor-Leste in 2002 to that in 2005?
Provide a short and direct response. 1.2. What is the ratio of the Value added (% of GDP) of Trinidad and Tobago in 2002 to that in 2005?
Give a very brief answer. 1.5. What is the ratio of the Value added (% of GDP) in Fiji in 2002 to that in 2006?
Keep it short and to the point. 1. What is the ratio of the Value added (% of GDP) in Sweden in 2002 to that in 2006?
Your response must be concise. 1.04. What is the ratio of the Value added (% of GDP) in Timor-Leste in 2002 to that in 2006?
Give a very brief answer. 1.16. What is the ratio of the Value added (% of GDP) of Trinidad and Tobago in 2002 to that in 2006?
Give a very brief answer. 1.49. What is the ratio of the Value added (% of GDP) in Fiji in 2003 to that in 2004?
Offer a very short reply. 0.92. What is the ratio of the Value added (% of GDP) of Sweden in 2003 to that in 2004?
Ensure brevity in your answer.  1.01. What is the ratio of the Value added (% of GDP) in Timor-Leste in 2003 to that in 2004?
Provide a succinct answer. 1.11. What is the ratio of the Value added (% of GDP) of Trinidad and Tobago in 2003 to that in 2004?
Make the answer very short. 0.95. What is the ratio of the Value added (% of GDP) of Fiji in 2003 to that in 2005?
Your answer should be very brief. 0.97. What is the ratio of the Value added (% of GDP) in Sweden in 2003 to that in 2005?
Your response must be concise. 1.01. What is the ratio of the Value added (% of GDP) of Timor-Leste in 2003 to that in 2005?
Offer a terse response. 1.18. What is the ratio of the Value added (% of GDP) of Trinidad and Tobago in 2003 to that in 2005?
Offer a very short reply. 1.19. What is the ratio of the Value added (% of GDP) of Fiji in 2003 to that in 2006?
Provide a succinct answer. 0.93. What is the ratio of the Value added (% of GDP) in Sweden in 2003 to that in 2006?
Your answer should be very brief. 1.01. What is the ratio of the Value added (% of GDP) of Timor-Leste in 2003 to that in 2006?
Provide a short and direct response. 1.15. What is the ratio of the Value added (% of GDP) of Trinidad and Tobago in 2003 to that in 2006?
Your answer should be compact. 1.18. What is the ratio of the Value added (% of GDP) of Fiji in 2004 to that in 2005?
Keep it short and to the point. 1.05. What is the ratio of the Value added (% of GDP) in Timor-Leste in 2004 to that in 2005?
Keep it short and to the point. 1.06. What is the ratio of the Value added (% of GDP) in Trinidad and Tobago in 2004 to that in 2005?
Offer a very short reply. 1.25. What is the ratio of the Value added (% of GDP) of Timor-Leste in 2004 to that in 2006?
Ensure brevity in your answer.  1.03. What is the ratio of the Value added (% of GDP) of Trinidad and Tobago in 2004 to that in 2006?
Provide a succinct answer. 1.24. What is the ratio of the Value added (% of GDP) in Fiji in 2005 to that in 2006?
Offer a terse response. 0.95. What is the ratio of the Value added (% of GDP) of Sweden in 2005 to that in 2006?
Your answer should be very brief. 1. What is the ratio of the Value added (% of GDP) in Timor-Leste in 2005 to that in 2006?
Provide a short and direct response. 0.97. What is the ratio of the Value added (% of GDP) in Trinidad and Tobago in 2005 to that in 2006?
Provide a short and direct response. 0.99. What is the difference between the highest and the second highest Value added (% of GDP) of Fiji?
Make the answer very short. 0.62. What is the difference between the highest and the second highest Value added (% of GDP) in Sweden?
Make the answer very short. 0.58. What is the difference between the highest and the second highest Value added (% of GDP) of Timor-Leste?
Keep it short and to the point. 0.04. What is the difference between the highest and the second highest Value added (% of GDP) in Trinidad and Tobago?
Your response must be concise. 0.63. What is the difference between the highest and the lowest Value added (% of GDP) in Fiji?
Ensure brevity in your answer.  1.8. What is the difference between the highest and the lowest Value added (% of GDP) in Sweden?
Your answer should be very brief. 1.35. What is the difference between the highest and the lowest Value added (% of GDP) in Timor-Leste?
Make the answer very short. 0.5. What is the difference between the highest and the lowest Value added (% of GDP) in Trinidad and Tobago?
Provide a succinct answer. 2.79. 